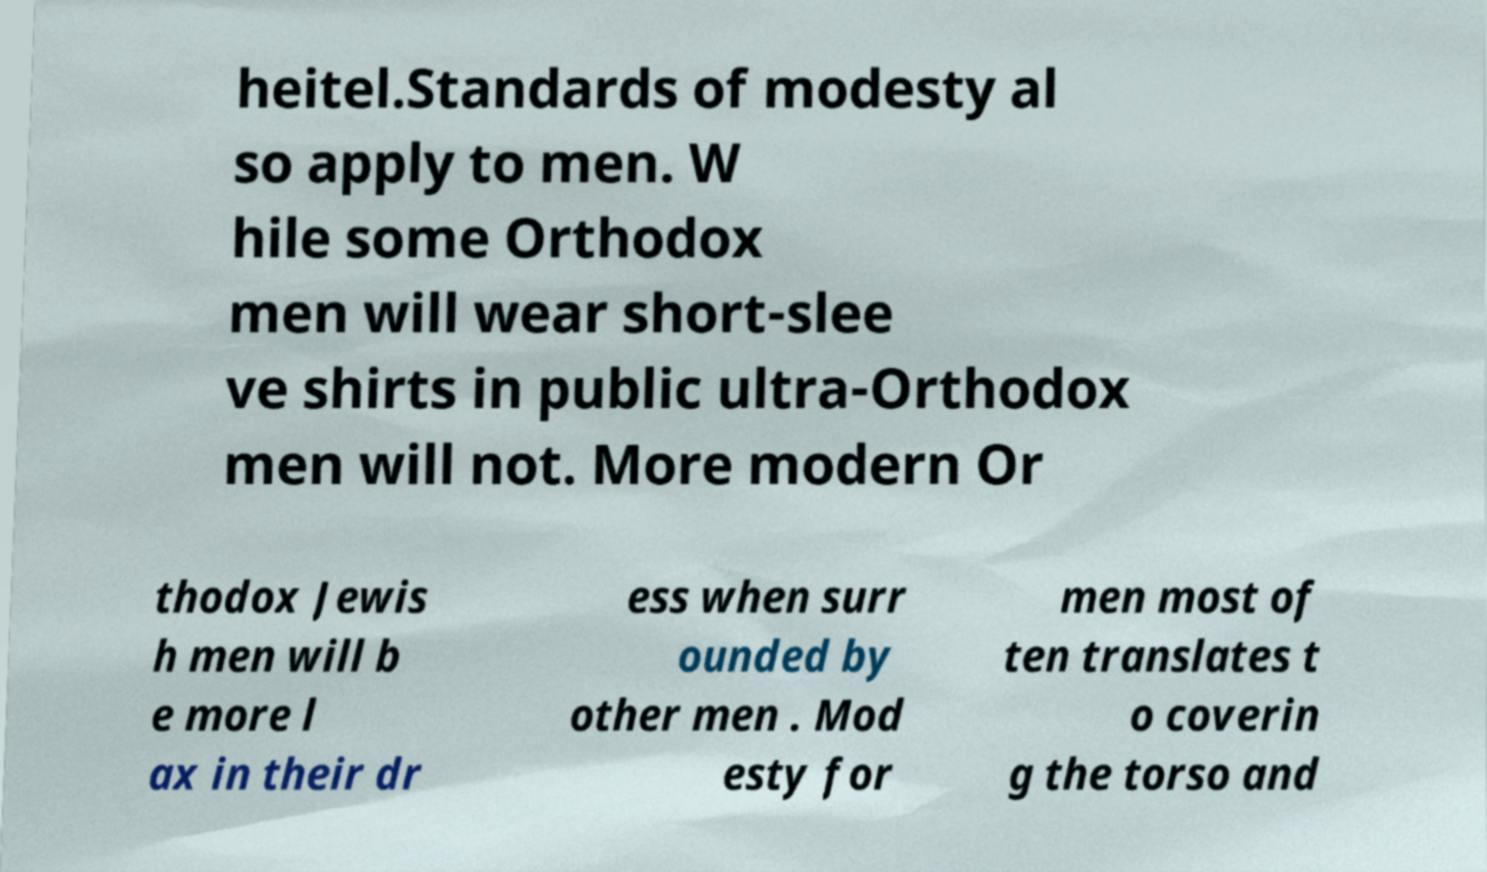I need the written content from this picture converted into text. Can you do that? heitel.Standards of modesty al so apply to men. W hile some Orthodox men will wear short-slee ve shirts in public ultra-Orthodox men will not. More modern Or thodox Jewis h men will b e more l ax in their dr ess when surr ounded by other men . Mod esty for men most of ten translates t o coverin g the torso and 